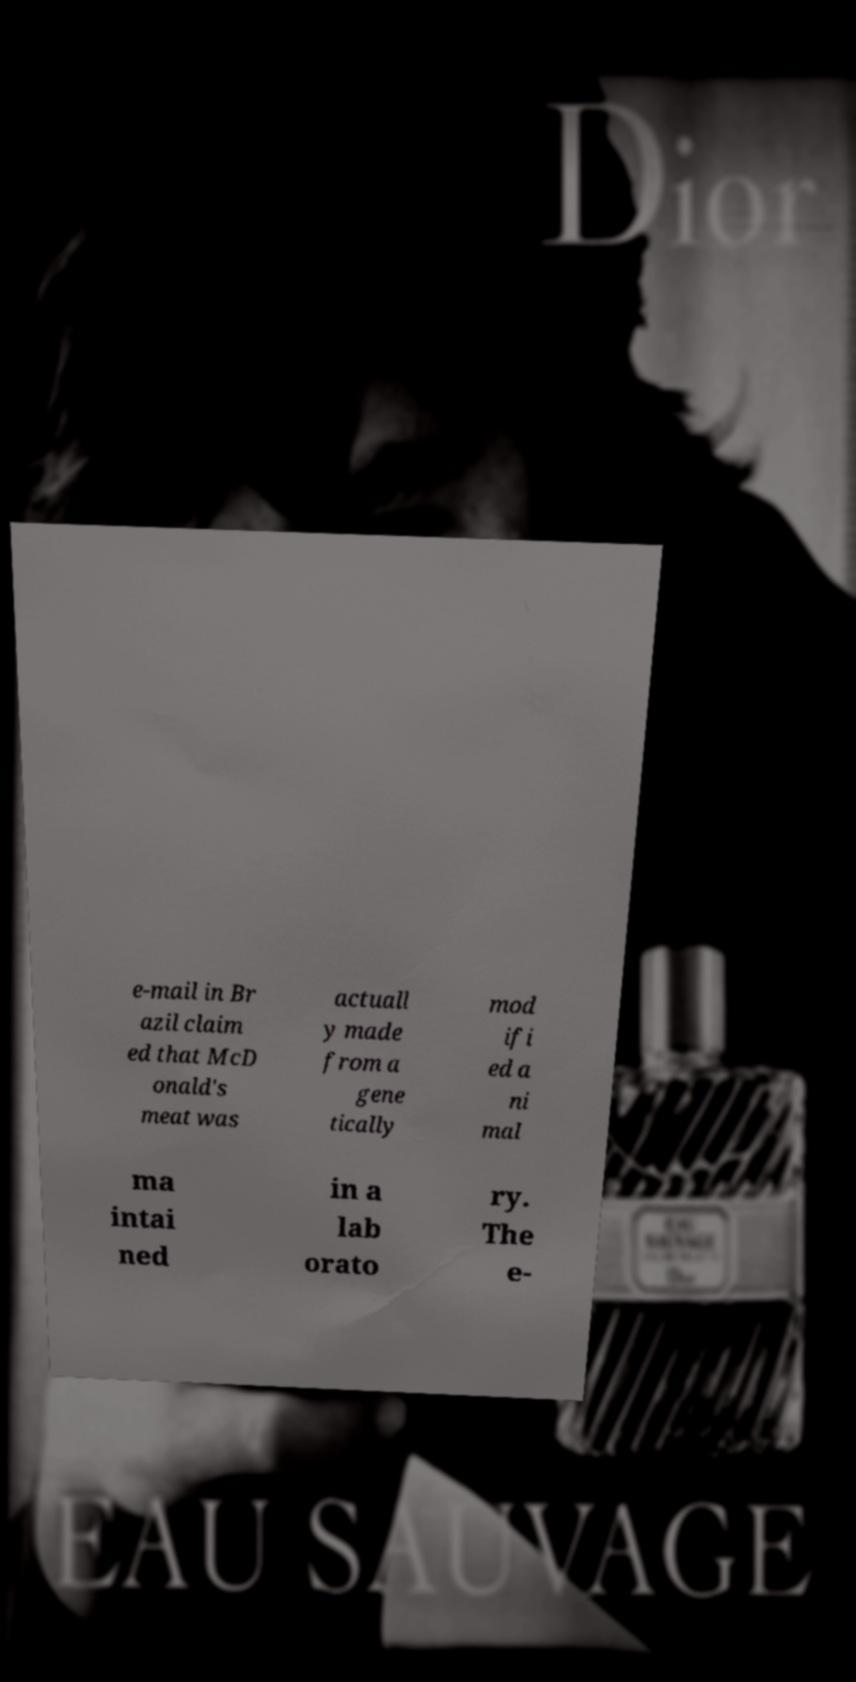Please identify and transcribe the text found in this image. e-mail in Br azil claim ed that McD onald's meat was actuall y made from a gene tically mod ifi ed a ni mal ma intai ned in a lab orato ry. The e- 